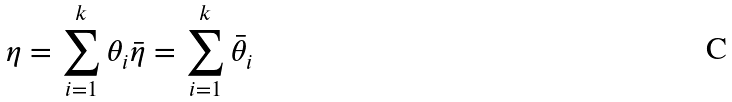<formula> <loc_0><loc_0><loc_500><loc_500>\eta = \sum _ { i = 1 } ^ { k } \theta _ { i } \bar { \eta } = \sum _ { i = 1 } ^ { k } \bar { \theta } _ { i }</formula> 